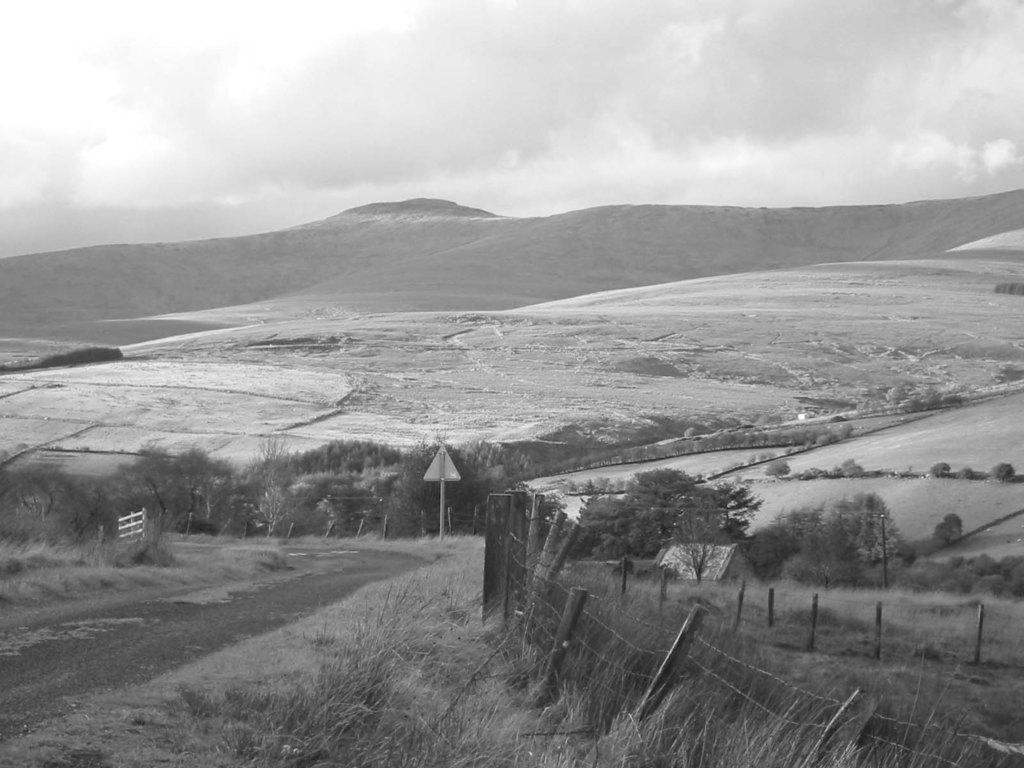What is the color scheme of the image? The image is black and white. What type of vegetation is present at the front of the image? There is grass on the surface at the front of the image. What can be seen in the background of the image? There are trees, mountains, and the sky visible in the background of the image. Can you see a ring on the grass in the image? There is no ring present on the grass in the image. Is there a porter carrying luggage in the image? There is no porter or luggage present in the image. 